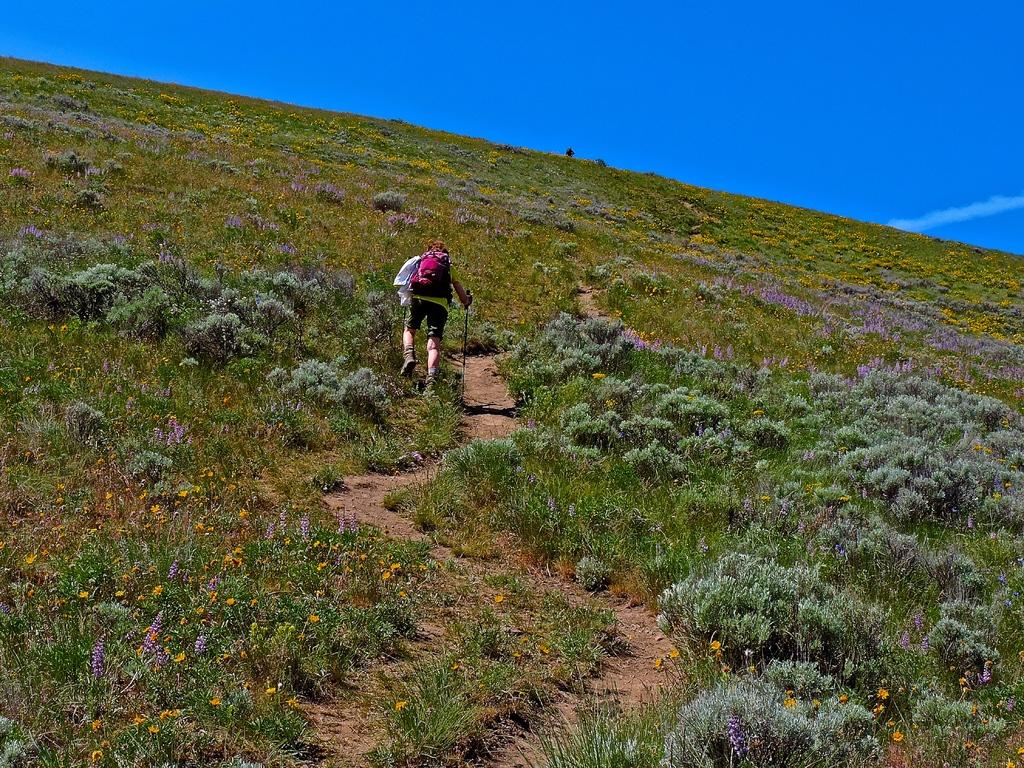What is the person in the image doing? The person is trekking in the image. What is the person carrying on their back? The person is wearing a bag. What tool is the person holding in the image? The person is holding a stick. What type of vegetation can be seen in the image? There is grass and flowers in the image. Where is the location of the image? The location is on a hill. What is visible at the top of the image? The sky is visible at the top of the image. What type of approval does the carpenter receive in the image? There is no carpenter present in the image, and therefore no approval can be given or received. 